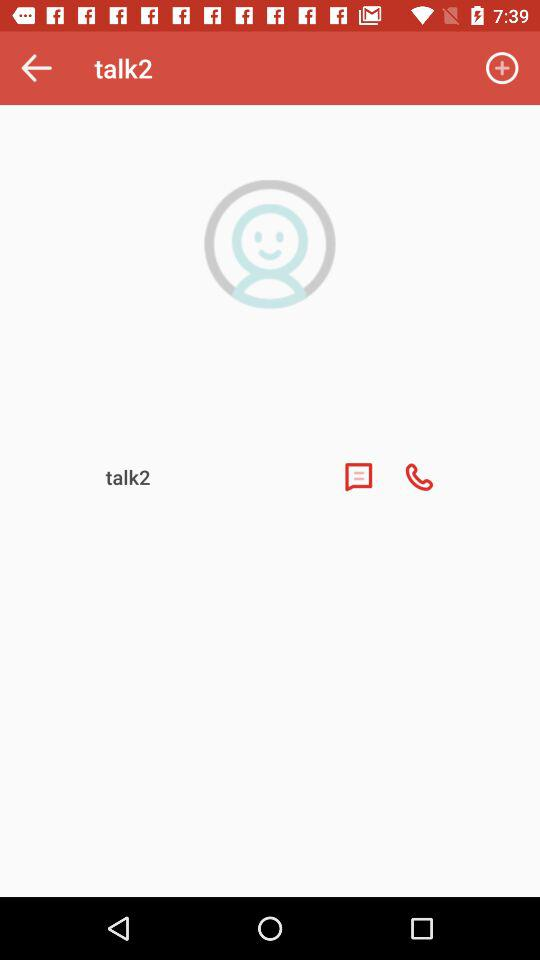What is the name of the application? The name of the application is "talk2". 